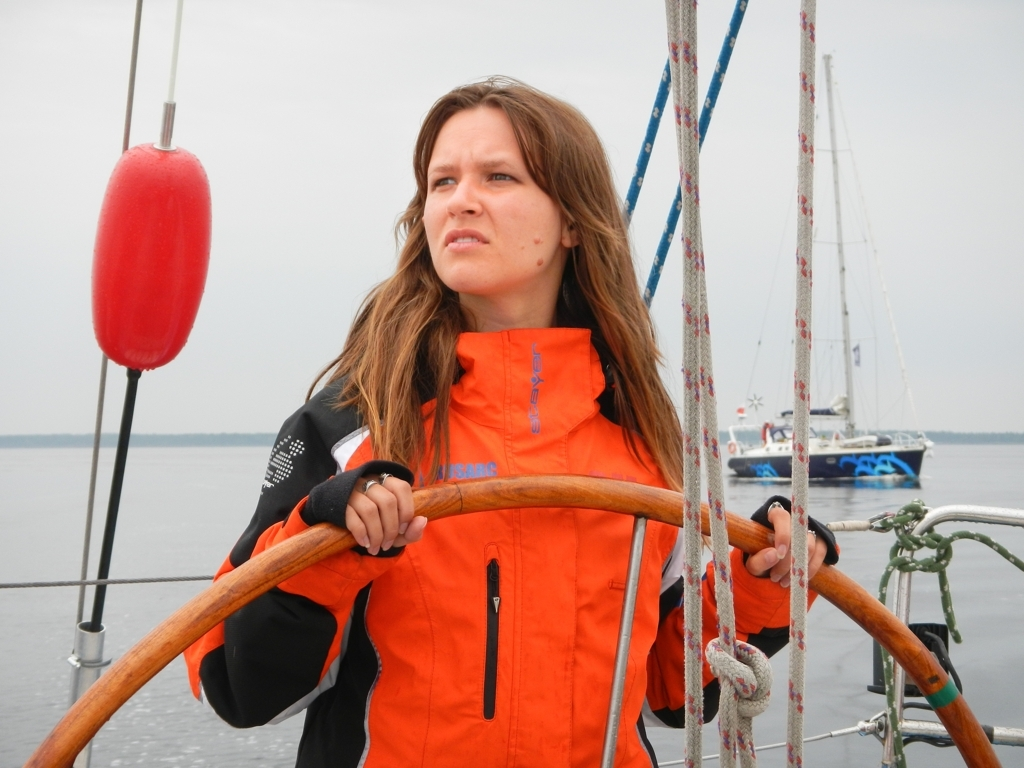Can you propose what activities the person might be involved in, based on the equipment seen in the image? Given the wooden wheel in the person’s hands and the presence of ropes and nautical equipment, it's reasonable to conclude that she is engaged in sailing. The equipment, such as the lifebuoy and visible masts of other sailboats in the background, all point to a sailing context, perhaps as a helmsperson responsible for steering and navigating the boat. 